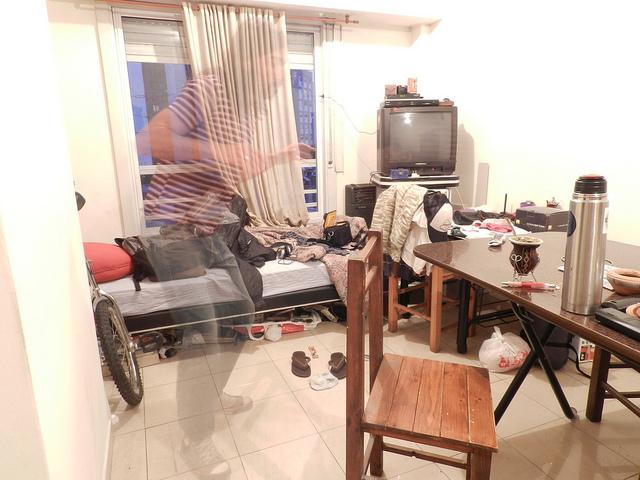The way the person appears makes them look like what type of being? Please explain your reasoning. ghost. The way is a ghost. 